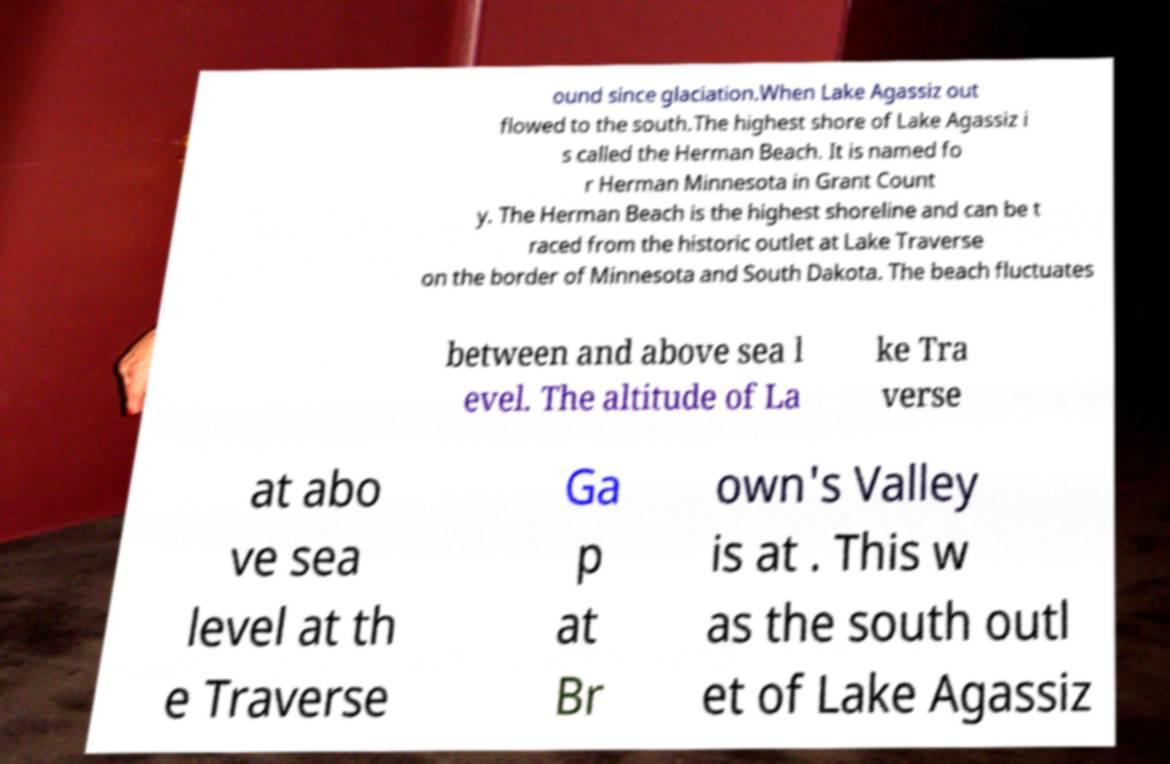Can you accurately transcribe the text from the provided image for me? ound since glaciation.When Lake Agassiz out flowed to the south.The highest shore of Lake Agassiz i s called the Herman Beach. It is named fo r Herman Minnesota in Grant Count y. The Herman Beach is the highest shoreline and can be t raced from the historic outlet at Lake Traverse on the border of Minnesota and South Dakota. The beach fluctuates between and above sea l evel. The altitude of La ke Tra verse at abo ve sea level at th e Traverse Ga p at Br own's Valley is at . This w as the south outl et of Lake Agassiz 